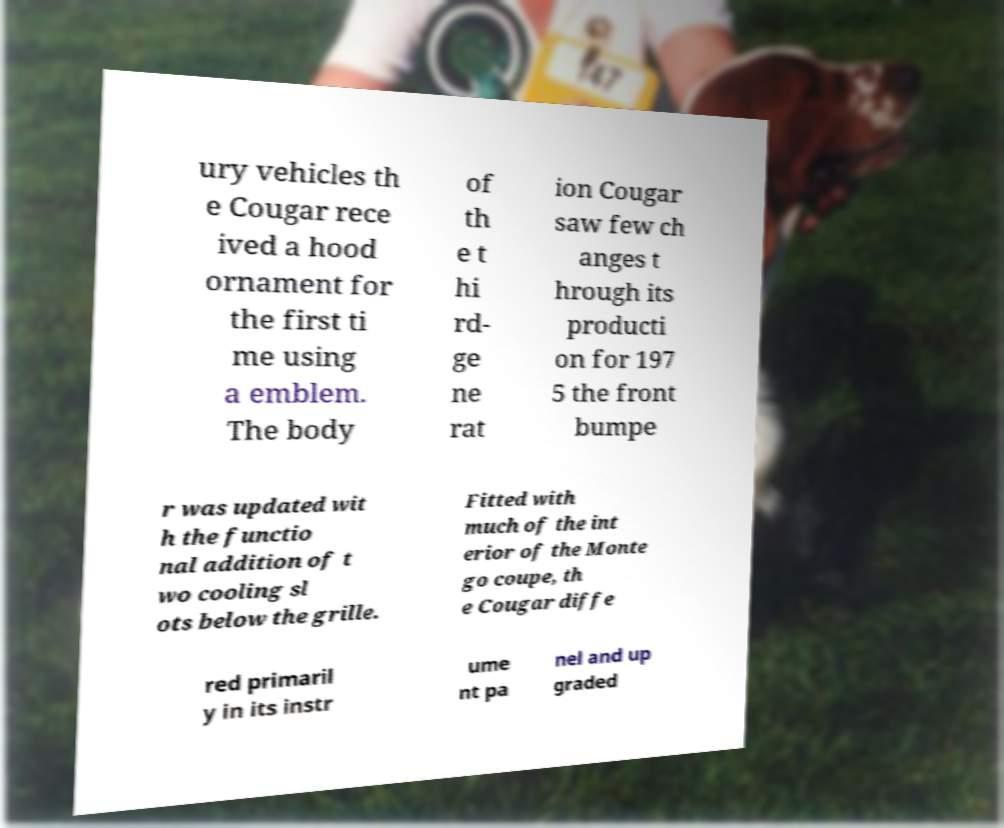Please identify and transcribe the text found in this image. ury vehicles th e Cougar rece ived a hood ornament for the first ti me using a emblem. The body of th e t hi rd- ge ne rat ion Cougar saw few ch anges t hrough its producti on for 197 5 the front bumpe r was updated wit h the functio nal addition of t wo cooling sl ots below the grille. Fitted with much of the int erior of the Monte go coupe, th e Cougar diffe red primaril y in its instr ume nt pa nel and up graded 